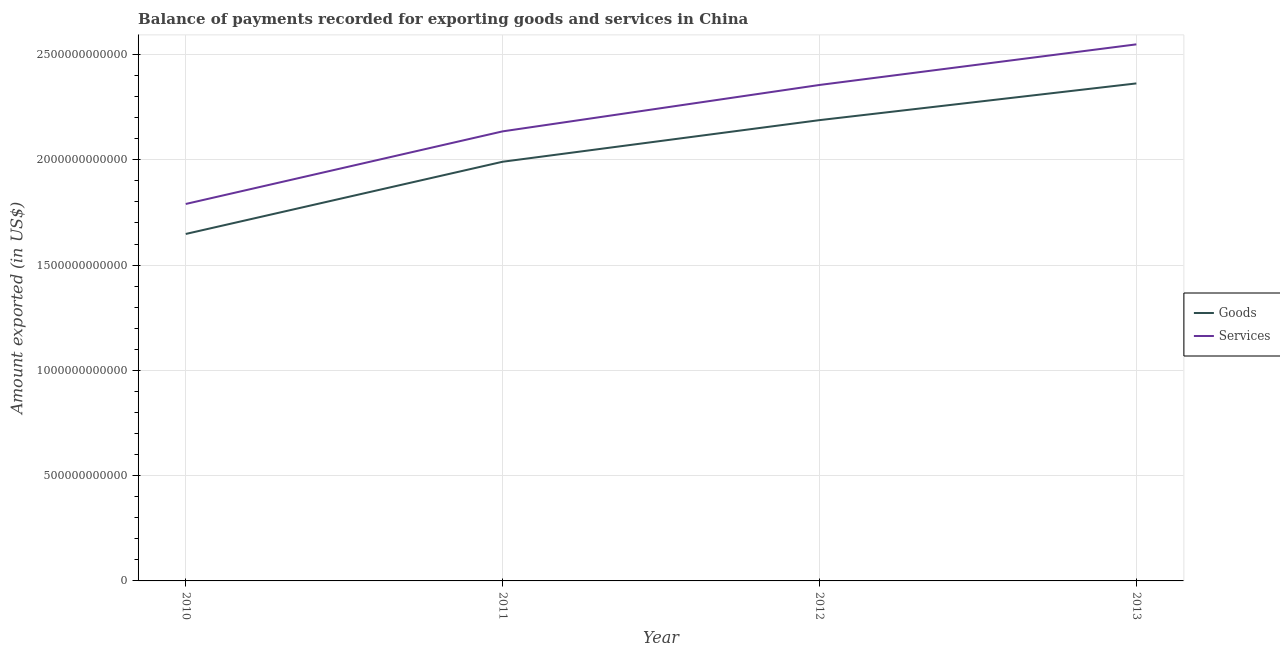How many different coloured lines are there?
Ensure brevity in your answer.  2. Does the line corresponding to amount of goods exported intersect with the line corresponding to amount of services exported?
Make the answer very short. No. Is the number of lines equal to the number of legend labels?
Make the answer very short. Yes. What is the amount of goods exported in 2013?
Your answer should be compact. 2.36e+12. Across all years, what is the maximum amount of services exported?
Offer a very short reply. 2.55e+12. Across all years, what is the minimum amount of services exported?
Offer a very short reply. 1.79e+12. In which year was the amount of goods exported minimum?
Provide a succinct answer. 2010. What is the total amount of services exported in the graph?
Offer a terse response. 8.83e+12. What is the difference between the amount of goods exported in 2010 and that in 2013?
Your answer should be very brief. -7.15e+11. What is the difference between the amount of goods exported in 2010 and the amount of services exported in 2011?
Your response must be concise. -4.87e+11. What is the average amount of services exported per year?
Keep it short and to the point. 2.21e+12. In the year 2012, what is the difference between the amount of goods exported and amount of services exported?
Provide a short and direct response. -1.67e+11. In how many years, is the amount of goods exported greater than 1500000000000 US$?
Your answer should be compact. 4. What is the ratio of the amount of services exported in 2011 to that in 2013?
Make the answer very short. 0.84. What is the difference between the highest and the second highest amount of services exported?
Your answer should be compact. 1.93e+11. What is the difference between the highest and the lowest amount of services exported?
Provide a succinct answer. 7.58e+11. In how many years, is the amount of goods exported greater than the average amount of goods exported taken over all years?
Make the answer very short. 2. Does the amount of services exported monotonically increase over the years?
Provide a succinct answer. Yes. Is the amount of goods exported strictly greater than the amount of services exported over the years?
Keep it short and to the point. No. Is the amount of services exported strictly less than the amount of goods exported over the years?
Give a very brief answer. No. What is the difference between two consecutive major ticks on the Y-axis?
Provide a succinct answer. 5.00e+11. Are the values on the major ticks of Y-axis written in scientific E-notation?
Keep it short and to the point. No. Does the graph contain grids?
Provide a short and direct response. Yes. Where does the legend appear in the graph?
Offer a terse response. Center right. How many legend labels are there?
Give a very brief answer. 2. What is the title of the graph?
Your answer should be compact. Balance of payments recorded for exporting goods and services in China. What is the label or title of the X-axis?
Give a very brief answer. Year. What is the label or title of the Y-axis?
Your answer should be compact. Amount exported (in US$). What is the Amount exported (in US$) of Goods in 2010?
Your answer should be very brief. 1.65e+12. What is the Amount exported (in US$) of Services in 2010?
Your answer should be compact. 1.79e+12. What is the Amount exported (in US$) in Goods in 2011?
Offer a very short reply. 1.99e+12. What is the Amount exported (in US$) of Services in 2011?
Give a very brief answer. 2.13e+12. What is the Amount exported (in US$) of Goods in 2012?
Keep it short and to the point. 2.19e+12. What is the Amount exported (in US$) in Services in 2012?
Keep it short and to the point. 2.36e+12. What is the Amount exported (in US$) in Goods in 2013?
Provide a succinct answer. 2.36e+12. What is the Amount exported (in US$) in Services in 2013?
Your response must be concise. 2.55e+12. Across all years, what is the maximum Amount exported (in US$) in Goods?
Give a very brief answer. 2.36e+12. Across all years, what is the maximum Amount exported (in US$) in Services?
Offer a terse response. 2.55e+12. Across all years, what is the minimum Amount exported (in US$) in Goods?
Ensure brevity in your answer.  1.65e+12. Across all years, what is the minimum Amount exported (in US$) of Services?
Provide a succinct answer. 1.79e+12. What is the total Amount exported (in US$) in Goods in the graph?
Provide a succinct answer. 8.19e+12. What is the total Amount exported (in US$) of Services in the graph?
Provide a succinct answer. 8.83e+12. What is the difference between the Amount exported (in US$) in Goods in 2010 and that in 2011?
Your answer should be very brief. -3.43e+11. What is the difference between the Amount exported (in US$) in Services in 2010 and that in 2011?
Make the answer very short. -3.45e+11. What is the difference between the Amount exported (in US$) in Goods in 2010 and that in 2012?
Offer a terse response. -5.41e+11. What is the difference between the Amount exported (in US$) of Services in 2010 and that in 2012?
Ensure brevity in your answer.  -5.65e+11. What is the difference between the Amount exported (in US$) in Goods in 2010 and that in 2013?
Offer a very short reply. -7.15e+11. What is the difference between the Amount exported (in US$) of Services in 2010 and that in 2013?
Keep it short and to the point. -7.58e+11. What is the difference between the Amount exported (in US$) of Goods in 2011 and that in 2012?
Your answer should be very brief. -1.98e+11. What is the difference between the Amount exported (in US$) in Services in 2011 and that in 2012?
Provide a succinct answer. -2.20e+11. What is the difference between the Amount exported (in US$) in Goods in 2011 and that in 2013?
Give a very brief answer. -3.72e+11. What is the difference between the Amount exported (in US$) in Services in 2011 and that in 2013?
Your answer should be very brief. -4.13e+11. What is the difference between the Amount exported (in US$) in Goods in 2012 and that in 2013?
Your answer should be very brief. -1.74e+11. What is the difference between the Amount exported (in US$) of Services in 2012 and that in 2013?
Provide a short and direct response. -1.93e+11. What is the difference between the Amount exported (in US$) of Goods in 2010 and the Amount exported (in US$) of Services in 2011?
Make the answer very short. -4.87e+11. What is the difference between the Amount exported (in US$) in Goods in 2010 and the Amount exported (in US$) in Services in 2012?
Give a very brief answer. -7.08e+11. What is the difference between the Amount exported (in US$) in Goods in 2010 and the Amount exported (in US$) in Services in 2013?
Make the answer very short. -9.00e+11. What is the difference between the Amount exported (in US$) in Goods in 2011 and the Amount exported (in US$) in Services in 2012?
Keep it short and to the point. -3.65e+11. What is the difference between the Amount exported (in US$) of Goods in 2011 and the Amount exported (in US$) of Services in 2013?
Provide a succinct answer. -5.57e+11. What is the difference between the Amount exported (in US$) of Goods in 2012 and the Amount exported (in US$) of Services in 2013?
Ensure brevity in your answer.  -3.60e+11. What is the average Amount exported (in US$) in Goods per year?
Provide a short and direct response. 2.05e+12. What is the average Amount exported (in US$) in Services per year?
Make the answer very short. 2.21e+12. In the year 2010, what is the difference between the Amount exported (in US$) of Goods and Amount exported (in US$) of Services?
Make the answer very short. -1.42e+11. In the year 2011, what is the difference between the Amount exported (in US$) of Goods and Amount exported (in US$) of Services?
Keep it short and to the point. -1.44e+11. In the year 2012, what is the difference between the Amount exported (in US$) of Goods and Amount exported (in US$) of Services?
Your answer should be very brief. -1.67e+11. In the year 2013, what is the difference between the Amount exported (in US$) of Goods and Amount exported (in US$) of Services?
Make the answer very short. -1.86e+11. What is the ratio of the Amount exported (in US$) in Goods in 2010 to that in 2011?
Provide a short and direct response. 0.83. What is the ratio of the Amount exported (in US$) in Services in 2010 to that in 2011?
Ensure brevity in your answer.  0.84. What is the ratio of the Amount exported (in US$) of Goods in 2010 to that in 2012?
Offer a terse response. 0.75. What is the ratio of the Amount exported (in US$) of Services in 2010 to that in 2012?
Provide a succinct answer. 0.76. What is the ratio of the Amount exported (in US$) of Goods in 2010 to that in 2013?
Make the answer very short. 0.7. What is the ratio of the Amount exported (in US$) of Services in 2010 to that in 2013?
Your answer should be very brief. 0.7. What is the ratio of the Amount exported (in US$) of Goods in 2011 to that in 2012?
Make the answer very short. 0.91. What is the ratio of the Amount exported (in US$) in Services in 2011 to that in 2012?
Your response must be concise. 0.91. What is the ratio of the Amount exported (in US$) in Goods in 2011 to that in 2013?
Make the answer very short. 0.84. What is the ratio of the Amount exported (in US$) of Services in 2011 to that in 2013?
Your response must be concise. 0.84. What is the ratio of the Amount exported (in US$) of Goods in 2012 to that in 2013?
Provide a short and direct response. 0.93. What is the ratio of the Amount exported (in US$) of Services in 2012 to that in 2013?
Your answer should be compact. 0.92. What is the difference between the highest and the second highest Amount exported (in US$) of Goods?
Offer a terse response. 1.74e+11. What is the difference between the highest and the second highest Amount exported (in US$) of Services?
Provide a short and direct response. 1.93e+11. What is the difference between the highest and the lowest Amount exported (in US$) in Goods?
Your response must be concise. 7.15e+11. What is the difference between the highest and the lowest Amount exported (in US$) in Services?
Your response must be concise. 7.58e+11. 